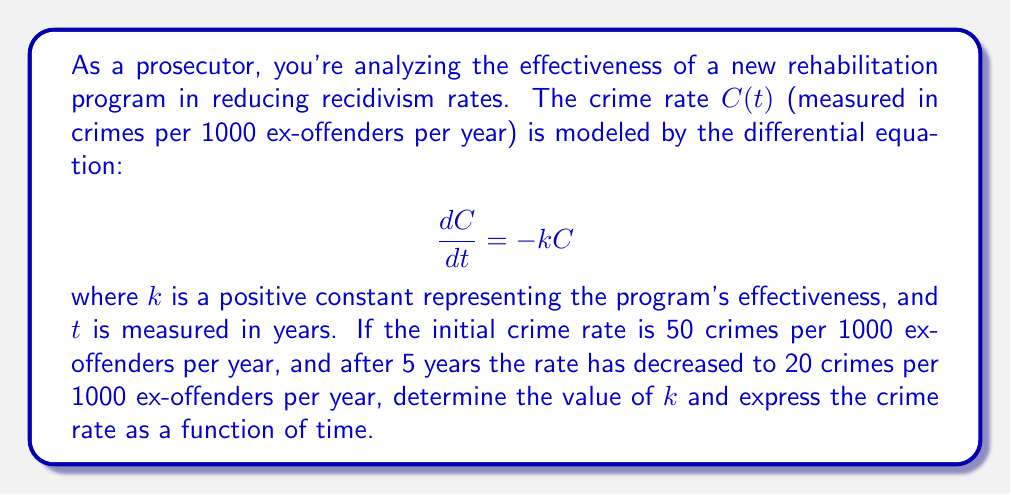Can you solve this math problem? Let's solve this problem step by step:

1) The given differential equation is a first-order linear equation:

   $$\frac{dC}{dt} = -kC$$

2) This equation can be solved by separation of variables:

   $$\frac{dC}{C} = -k dt$$

3) Integrating both sides:

   $$\int \frac{dC}{C} = -k \int dt$$
   $$\ln|C| = -kt + A$$, where A is a constant of integration

4) Taking the exponential of both sides:

   $$C = e^{-kt + A} = Be^{-kt}$$, where $B = e^A$

5) We're given the initial condition $C(0) = 50$. Applying this:

   $$50 = Be^{-k(0)} = B$$

6) So our general solution is:

   $$C(t) = 50e^{-kt}$$

7) We're also given that after 5 years, $C(5) = 20$. Let's use this to find $k$:

   $$20 = 50e^{-k(5)}$$
   $$\frac{2}{5} = e^{-5k}$$
   $$\ln(\frac{2}{5}) = -5k$$
   $$k = -\frac{1}{5}\ln(\frac{2}{5}) \approx 0.1823$$

8) Now that we have $k$, we can write our final solution:

   $$C(t) = 50e^{-0.1823t}$$

This equation models the crime rate as a function of time, where $t$ is measured in years.
Answer: $k \approx 0.1823$, and $C(t) = 50e^{-0.1823t}$ 